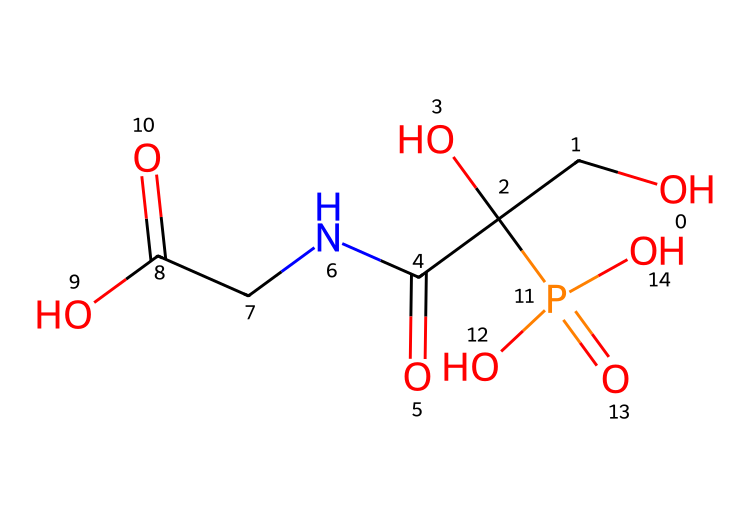What is the molecular formula of glyphosate as represented in the SMILES? To determine the molecular formula, identify all the distinct atoms present in the chemical structure: C (carbon), H (hydrogen), N (nitrogen), O (oxygen), and P (phosphorus). Counting the atoms results in C5, H8, N1, O5, P1. Therefore, the molecular formula is C5H8N1O5P1.
Answer: C5H8N1O5P1 How many carbon atoms are in glyphosate? The molecular structure in the SMILES indicates five carbon atoms based on its composition, which can be observed by counting the 'C' symbols present in the molecular structure.
Answer: 5 What type of compound is glyphosate? Glyphosate is classified as a phosphonic acid herbicide. This classification comes from its presence of a phosphorus atom (P) and functional groups commonly associated with herbicides.
Answer: phosphonic acid herbicide How many total oxygen atoms are present in glyphosate? In the given SMILES, the oxygen (O) atoms can be counted to a total of five occurrences. Therefore, there are five oxygen atoms in glyphosate.
Answer: 5 What is the main functional group of glyphosate? The main functional group in glyphosate, as identified in the SMILES, is the phosphonic acid group, which is characterized by the P=O and P-O bonds. This group's presence is key to the chemical's herbicidal activity.
Answer: phosphonic acid group Why is phosphorus important in glyphosate? Phosphorus serves a crucial role in glyphosate's structure by providing the herbicidal activity through the phosphonic acid moiety, which helps in the inhibition of certain enzymes critical for plant growth.
Answer: herbicidal activity 